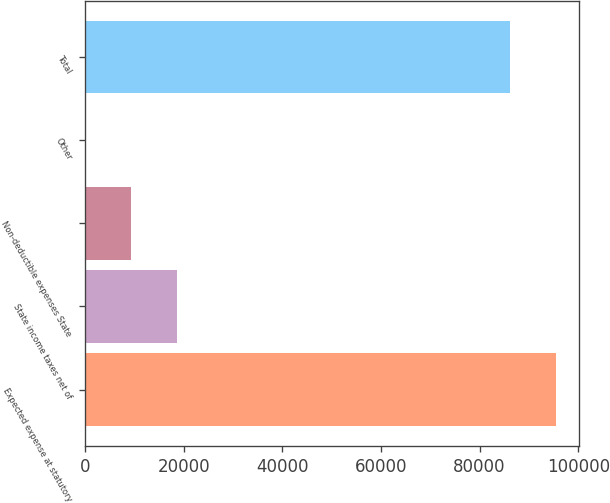Convert chart to OTSL. <chart><loc_0><loc_0><loc_500><loc_500><bar_chart><fcel>Expected expense at statutory<fcel>State income taxes net of<fcel>Non-deductible expenses State<fcel>Other<fcel>Total<nl><fcel>95405.7<fcel>18601.4<fcel>9422.7<fcel>244<fcel>86227<nl></chart> 